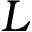<formula> <loc_0><loc_0><loc_500><loc_500>L</formula> 